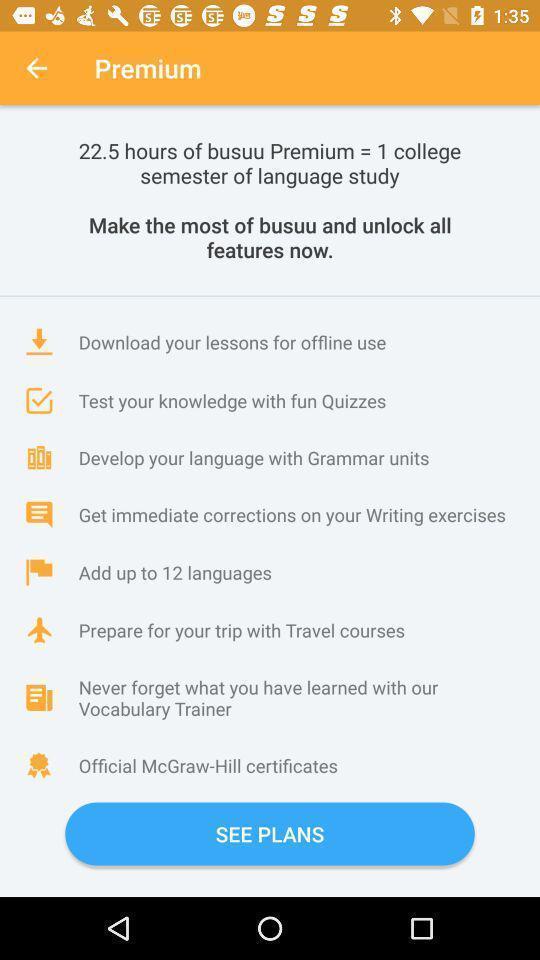Please provide a description for this image. Screen page displaying features. 